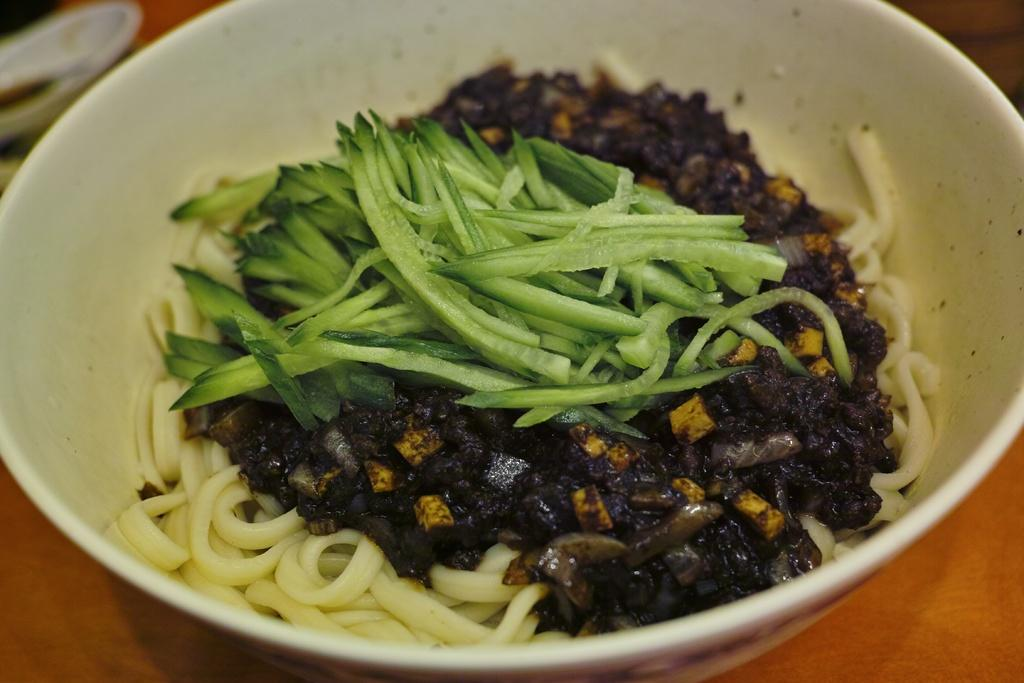What is the main subject of the image? There is a food item in the image. How is the food item contained in the image? The food item is in a bowl. What type of surface is the bowl placed on? The bowl is placed on a wooden surface. What type of corn can be seen growing on the wooden surface in the image? There is no corn visible in the image, and the wooden surface is not a field for growing crops. 